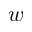<formula> <loc_0><loc_0><loc_500><loc_500>w</formula> 